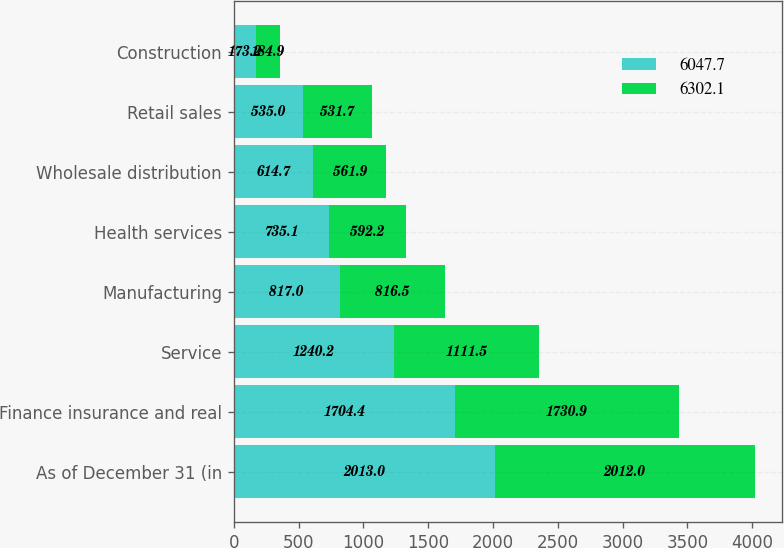Convert chart. <chart><loc_0><loc_0><loc_500><loc_500><stacked_bar_chart><ecel><fcel>As of December 31 (in<fcel>Finance insurance and real<fcel>Service<fcel>Manufacturing<fcel>Health services<fcel>Wholesale distribution<fcel>Retail sales<fcel>Construction<nl><fcel>6047.7<fcel>2013<fcel>1704.4<fcel>1240.2<fcel>817<fcel>735.1<fcel>614.7<fcel>535<fcel>173.2<nl><fcel>6302.1<fcel>2012<fcel>1730.9<fcel>1111.5<fcel>816.5<fcel>592.2<fcel>561.9<fcel>531.7<fcel>184.9<nl></chart> 